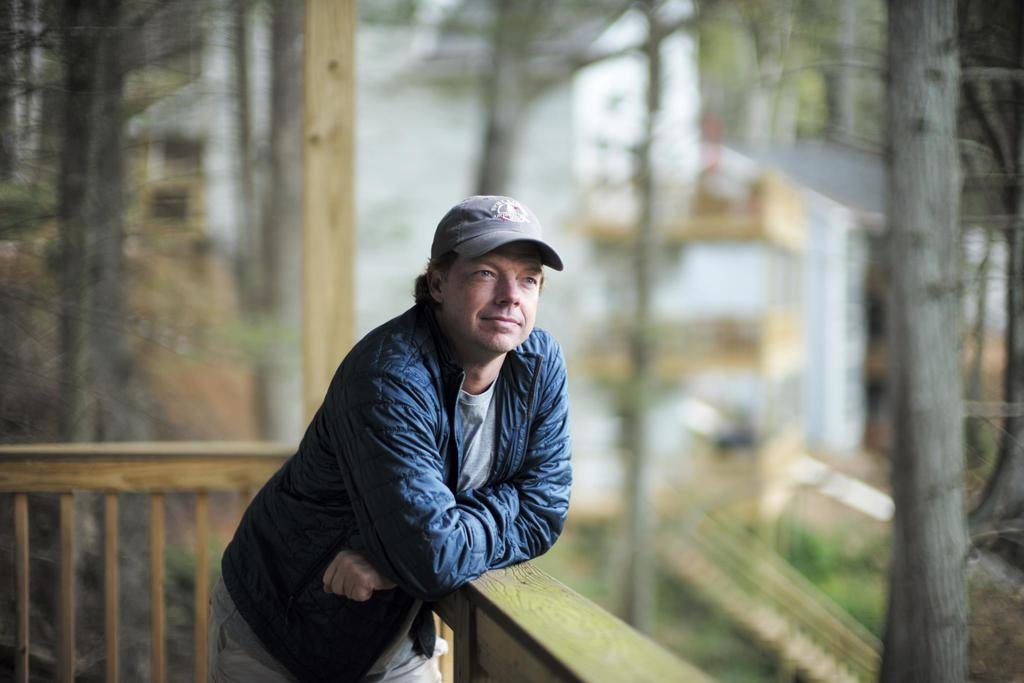Who is present in the image? There is a man in the image. What is the man wearing on his upper body? The man is wearing a jacket. What is the man wearing on his head? The man is wearing a cap. What can be seen in the background of the image? There is a wooden railing in the background of the image. Where is the man standing in relation to a wooden structure? The man is standing near a wooden stand. How would you describe the background of the image? The background of the image is blurred. Can you see any goldfish swimming in the image? There are no goldfish present in the image. What type of fruit is the man holding in the image? The man is not holding any fruit in the image. 